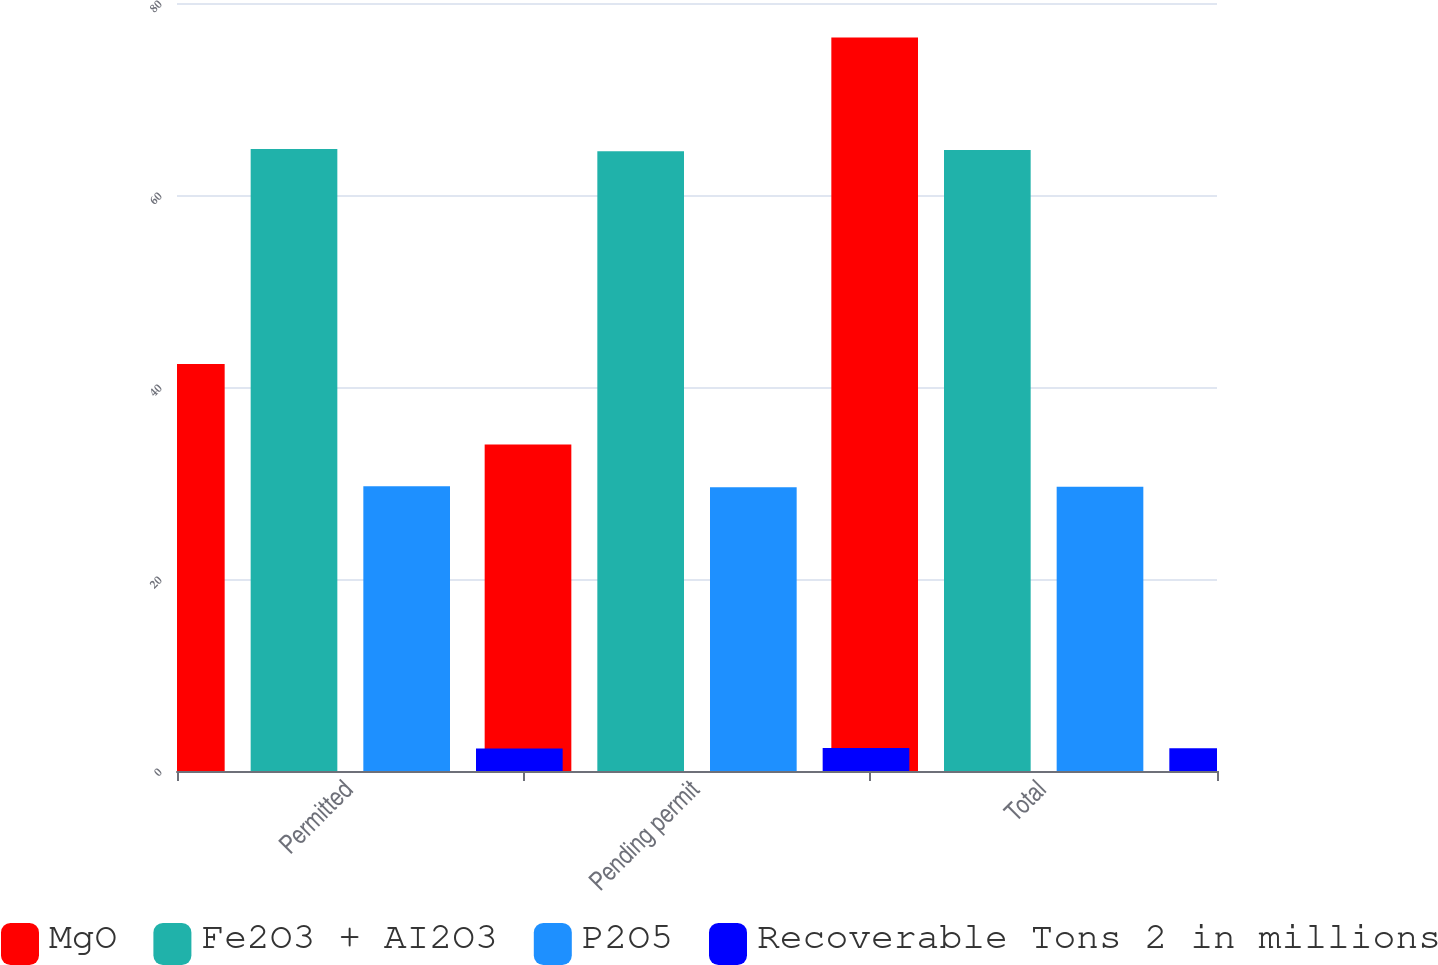Convert chart to OTSL. <chart><loc_0><loc_0><loc_500><loc_500><stacked_bar_chart><ecel><fcel>Permitted<fcel>Pending permit<fcel>Total<nl><fcel>MgO<fcel>42.4<fcel>34<fcel>76.4<nl><fcel>Fe2O3 + AI2O3<fcel>64.79<fcel>64.57<fcel>64.7<nl><fcel>P2O5<fcel>29.65<fcel>29.55<fcel>29.61<nl><fcel>Recoverable Tons 2 in millions<fcel>2.35<fcel>2.39<fcel>2.37<nl></chart> 